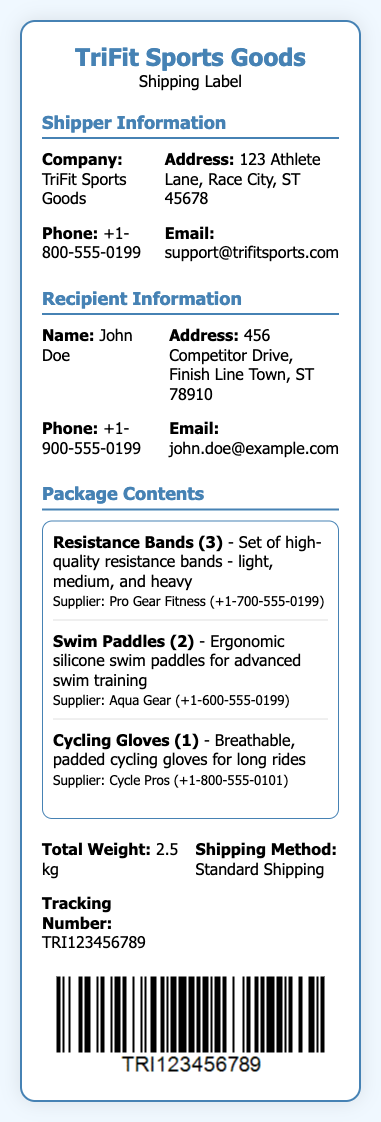What is the company name? The company name is located in the Shipper Information section of the document.
Answer: TriFit Sports Goods What is the recipient's address? The address for the recipient can be found in the Recipient Information section.
Answer: 456 Competitor Drive, Finish Line Town, ST 78910 How many swim paddles are included in the package? The quantity of swim paddles is mentioned in the Package Contents section under Swim Paddles.
Answer: 2 What is the total weight of the package? The total weight is specified in the info grid at the bottom of the document.
Answer: 2.5 kg What is the shipping method? The method of shipping is stated in the info grid section of the label.
Answer: Standard Shipping Who is the supplier of the resistance bands? The supplier information for the resistance bands is provided in the Package Contents section.
Answer: Pro Gear Fitness What is the tracking number? The tracking number is listed in the info grid at the bottom of the shipping label.
Answer: TRI123456789 What type of gloves are included? The type of gloves can be found in the Package Contents section.
Answer: Cycling Gloves What is the email address of the shipper? The email information is located in the Shipper Information section of the document.
Answer: support@trifitsports.com 